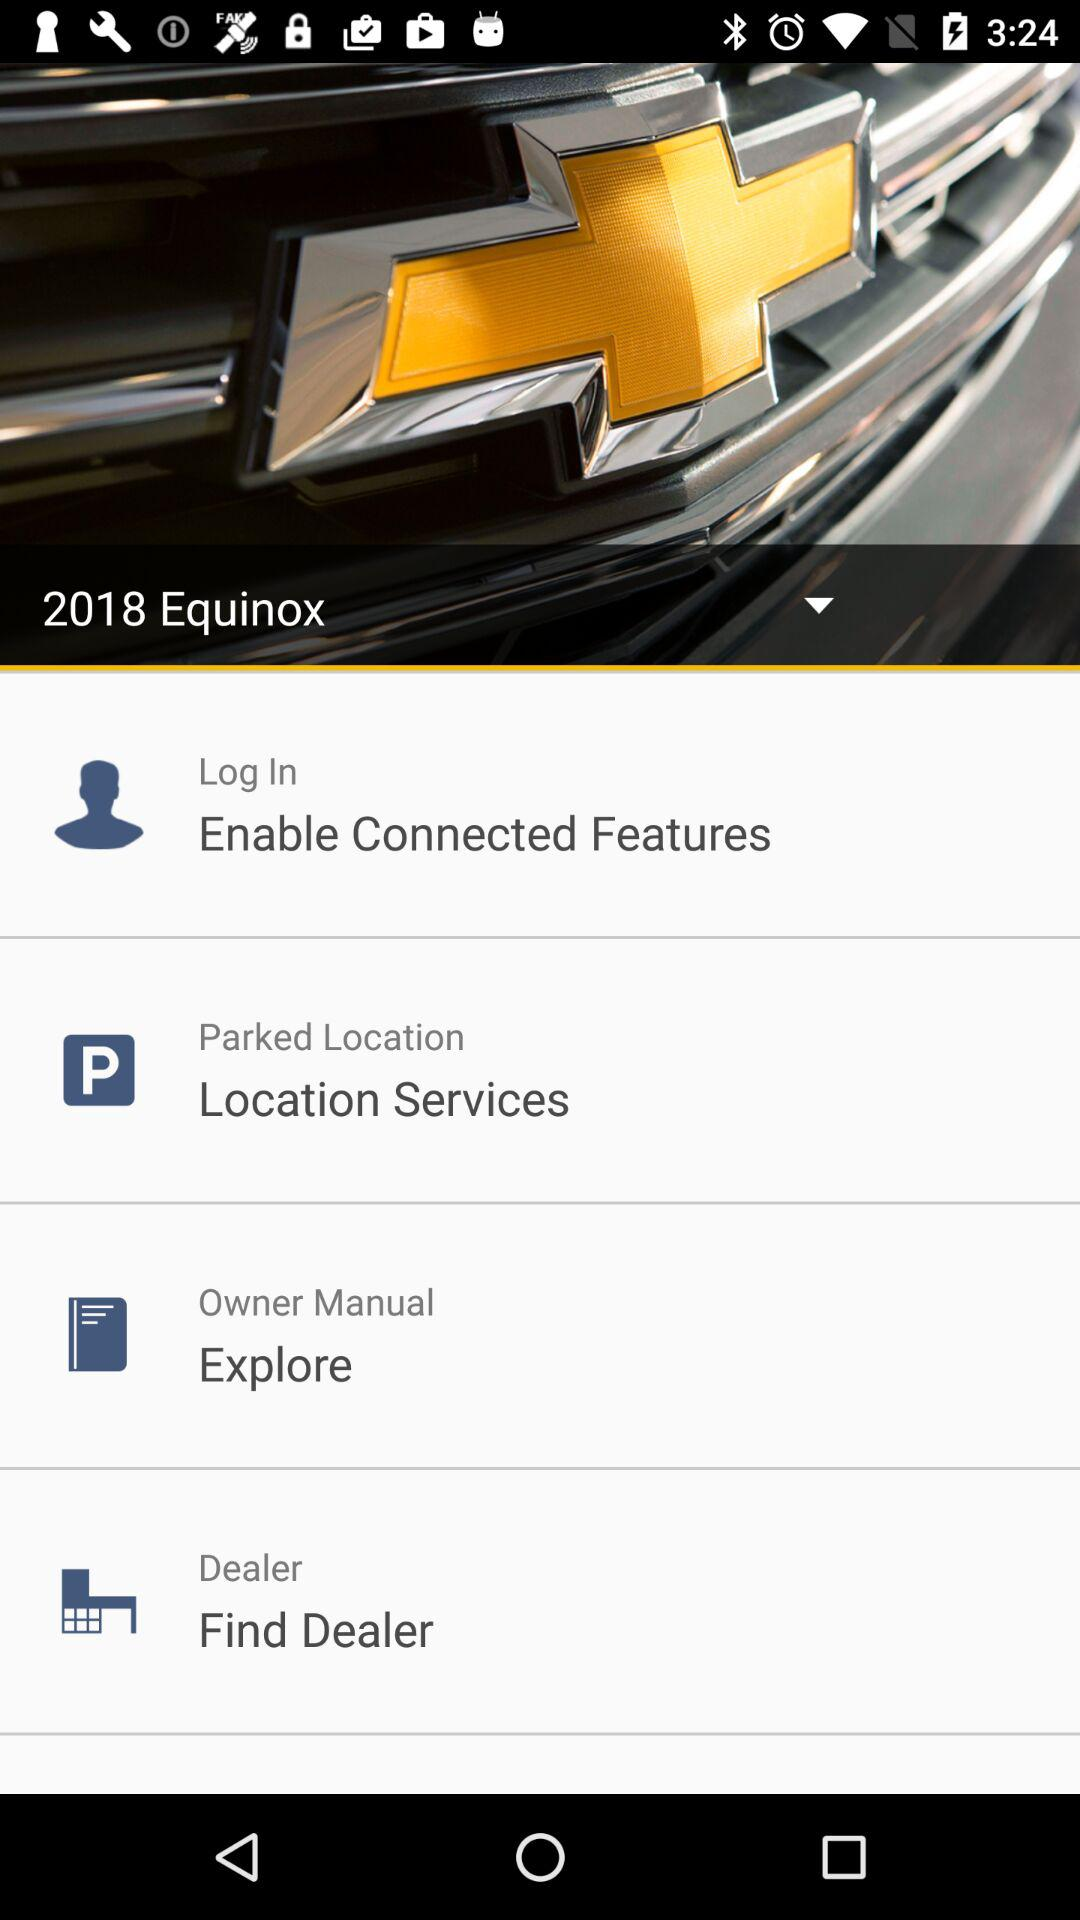Which model of car is selected? The selected model of car is the 2018 Equinox. 